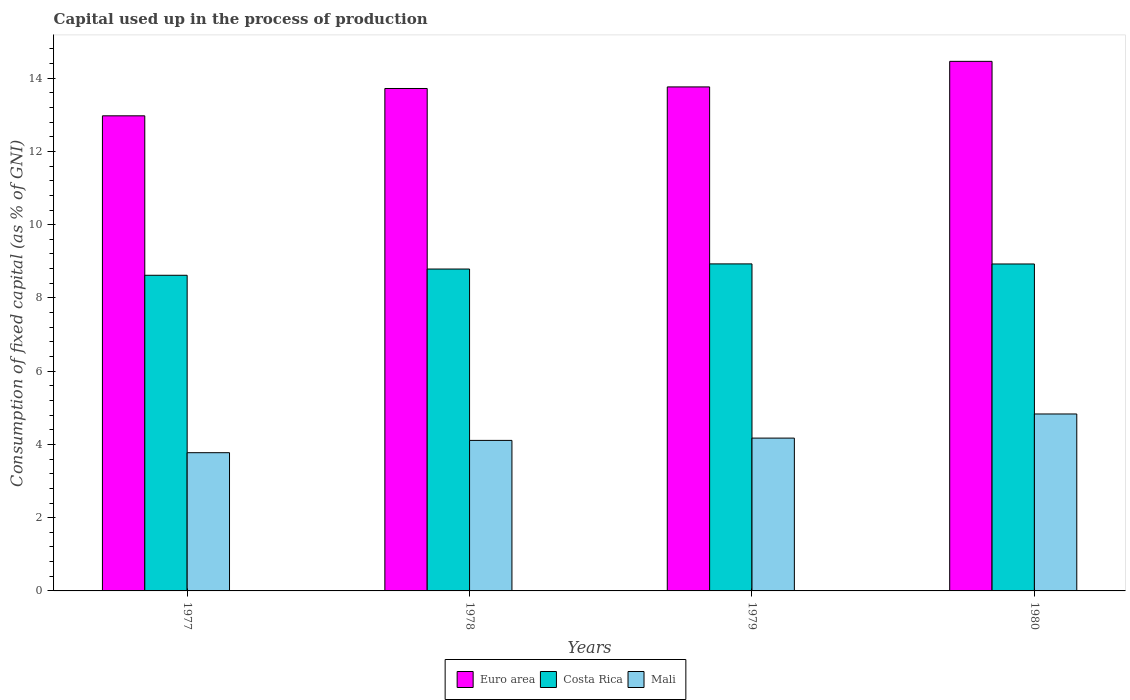How many different coloured bars are there?
Offer a terse response. 3. How many groups of bars are there?
Give a very brief answer. 4. Are the number of bars on each tick of the X-axis equal?
Your response must be concise. Yes. How many bars are there on the 1st tick from the right?
Your answer should be very brief. 3. What is the capital used up in the process of production in Mali in 1979?
Your response must be concise. 4.17. Across all years, what is the maximum capital used up in the process of production in Costa Rica?
Make the answer very short. 8.93. Across all years, what is the minimum capital used up in the process of production in Euro area?
Provide a short and direct response. 12.97. In which year was the capital used up in the process of production in Euro area maximum?
Offer a terse response. 1980. In which year was the capital used up in the process of production in Mali minimum?
Offer a very short reply. 1977. What is the total capital used up in the process of production in Mali in the graph?
Offer a terse response. 16.89. What is the difference between the capital used up in the process of production in Euro area in 1978 and that in 1980?
Your answer should be compact. -0.74. What is the difference between the capital used up in the process of production in Mali in 1977 and the capital used up in the process of production in Costa Rica in 1980?
Ensure brevity in your answer.  -5.15. What is the average capital used up in the process of production in Mali per year?
Offer a terse response. 4.22. In the year 1977, what is the difference between the capital used up in the process of production in Costa Rica and capital used up in the process of production in Euro area?
Your answer should be compact. -4.35. What is the ratio of the capital used up in the process of production in Mali in 1977 to that in 1979?
Offer a very short reply. 0.9. Is the difference between the capital used up in the process of production in Costa Rica in 1978 and 1979 greater than the difference between the capital used up in the process of production in Euro area in 1978 and 1979?
Your response must be concise. No. What is the difference between the highest and the second highest capital used up in the process of production in Euro area?
Make the answer very short. 0.7. What is the difference between the highest and the lowest capital used up in the process of production in Mali?
Keep it short and to the point. 1.06. Is the sum of the capital used up in the process of production in Costa Rica in 1978 and 1979 greater than the maximum capital used up in the process of production in Euro area across all years?
Keep it short and to the point. Yes. What does the 3rd bar from the left in 1977 represents?
Provide a short and direct response. Mali. How many bars are there?
Give a very brief answer. 12. Are all the bars in the graph horizontal?
Provide a short and direct response. No. How many years are there in the graph?
Offer a terse response. 4. Does the graph contain any zero values?
Make the answer very short. No. Where does the legend appear in the graph?
Ensure brevity in your answer.  Bottom center. How many legend labels are there?
Offer a terse response. 3. How are the legend labels stacked?
Give a very brief answer. Horizontal. What is the title of the graph?
Offer a terse response. Capital used up in the process of production. What is the label or title of the X-axis?
Provide a succinct answer. Years. What is the label or title of the Y-axis?
Your answer should be compact. Consumption of fixed capital (as % of GNI). What is the Consumption of fixed capital (as % of GNI) in Euro area in 1977?
Offer a very short reply. 12.97. What is the Consumption of fixed capital (as % of GNI) of Costa Rica in 1977?
Your answer should be very brief. 8.62. What is the Consumption of fixed capital (as % of GNI) in Mali in 1977?
Give a very brief answer. 3.77. What is the Consumption of fixed capital (as % of GNI) in Euro area in 1978?
Ensure brevity in your answer.  13.72. What is the Consumption of fixed capital (as % of GNI) in Costa Rica in 1978?
Keep it short and to the point. 8.79. What is the Consumption of fixed capital (as % of GNI) of Mali in 1978?
Provide a short and direct response. 4.11. What is the Consumption of fixed capital (as % of GNI) in Euro area in 1979?
Offer a terse response. 13.76. What is the Consumption of fixed capital (as % of GNI) in Costa Rica in 1979?
Provide a succinct answer. 8.93. What is the Consumption of fixed capital (as % of GNI) in Mali in 1979?
Provide a succinct answer. 4.17. What is the Consumption of fixed capital (as % of GNI) of Euro area in 1980?
Offer a very short reply. 14.46. What is the Consumption of fixed capital (as % of GNI) of Costa Rica in 1980?
Ensure brevity in your answer.  8.93. What is the Consumption of fixed capital (as % of GNI) in Mali in 1980?
Provide a succinct answer. 4.83. Across all years, what is the maximum Consumption of fixed capital (as % of GNI) in Euro area?
Provide a short and direct response. 14.46. Across all years, what is the maximum Consumption of fixed capital (as % of GNI) in Costa Rica?
Offer a terse response. 8.93. Across all years, what is the maximum Consumption of fixed capital (as % of GNI) of Mali?
Provide a succinct answer. 4.83. Across all years, what is the minimum Consumption of fixed capital (as % of GNI) of Euro area?
Provide a succinct answer. 12.97. Across all years, what is the minimum Consumption of fixed capital (as % of GNI) of Costa Rica?
Make the answer very short. 8.62. Across all years, what is the minimum Consumption of fixed capital (as % of GNI) of Mali?
Ensure brevity in your answer.  3.77. What is the total Consumption of fixed capital (as % of GNI) of Euro area in the graph?
Make the answer very short. 54.91. What is the total Consumption of fixed capital (as % of GNI) of Costa Rica in the graph?
Your response must be concise. 35.26. What is the total Consumption of fixed capital (as % of GNI) in Mali in the graph?
Offer a very short reply. 16.89. What is the difference between the Consumption of fixed capital (as % of GNI) in Euro area in 1977 and that in 1978?
Ensure brevity in your answer.  -0.75. What is the difference between the Consumption of fixed capital (as % of GNI) of Costa Rica in 1977 and that in 1978?
Offer a very short reply. -0.17. What is the difference between the Consumption of fixed capital (as % of GNI) in Mali in 1977 and that in 1978?
Your response must be concise. -0.34. What is the difference between the Consumption of fixed capital (as % of GNI) in Euro area in 1977 and that in 1979?
Provide a succinct answer. -0.79. What is the difference between the Consumption of fixed capital (as % of GNI) in Costa Rica in 1977 and that in 1979?
Offer a very short reply. -0.31. What is the difference between the Consumption of fixed capital (as % of GNI) of Mali in 1977 and that in 1979?
Your response must be concise. -0.4. What is the difference between the Consumption of fixed capital (as % of GNI) in Euro area in 1977 and that in 1980?
Offer a very short reply. -1.49. What is the difference between the Consumption of fixed capital (as % of GNI) of Costa Rica in 1977 and that in 1980?
Give a very brief answer. -0.31. What is the difference between the Consumption of fixed capital (as % of GNI) in Mali in 1977 and that in 1980?
Provide a succinct answer. -1.06. What is the difference between the Consumption of fixed capital (as % of GNI) in Euro area in 1978 and that in 1979?
Your answer should be compact. -0.04. What is the difference between the Consumption of fixed capital (as % of GNI) in Costa Rica in 1978 and that in 1979?
Your answer should be compact. -0.14. What is the difference between the Consumption of fixed capital (as % of GNI) in Mali in 1978 and that in 1979?
Offer a very short reply. -0.06. What is the difference between the Consumption of fixed capital (as % of GNI) of Euro area in 1978 and that in 1980?
Your response must be concise. -0.74. What is the difference between the Consumption of fixed capital (as % of GNI) in Costa Rica in 1978 and that in 1980?
Make the answer very short. -0.14. What is the difference between the Consumption of fixed capital (as % of GNI) of Mali in 1978 and that in 1980?
Your answer should be compact. -0.72. What is the difference between the Consumption of fixed capital (as % of GNI) of Euro area in 1979 and that in 1980?
Provide a short and direct response. -0.7. What is the difference between the Consumption of fixed capital (as % of GNI) in Costa Rica in 1979 and that in 1980?
Ensure brevity in your answer.  0. What is the difference between the Consumption of fixed capital (as % of GNI) of Mali in 1979 and that in 1980?
Provide a short and direct response. -0.66. What is the difference between the Consumption of fixed capital (as % of GNI) of Euro area in 1977 and the Consumption of fixed capital (as % of GNI) of Costa Rica in 1978?
Give a very brief answer. 4.18. What is the difference between the Consumption of fixed capital (as % of GNI) of Euro area in 1977 and the Consumption of fixed capital (as % of GNI) of Mali in 1978?
Provide a short and direct response. 8.86. What is the difference between the Consumption of fixed capital (as % of GNI) of Costa Rica in 1977 and the Consumption of fixed capital (as % of GNI) of Mali in 1978?
Provide a short and direct response. 4.51. What is the difference between the Consumption of fixed capital (as % of GNI) in Euro area in 1977 and the Consumption of fixed capital (as % of GNI) in Costa Rica in 1979?
Your answer should be very brief. 4.04. What is the difference between the Consumption of fixed capital (as % of GNI) of Euro area in 1977 and the Consumption of fixed capital (as % of GNI) of Mali in 1979?
Provide a succinct answer. 8.8. What is the difference between the Consumption of fixed capital (as % of GNI) in Costa Rica in 1977 and the Consumption of fixed capital (as % of GNI) in Mali in 1979?
Your answer should be compact. 4.45. What is the difference between the Consumption of fixed capital (as % of GNI) in Euro area in 1977 and the Consumption of fixed capital (as % of GNI) in Costa Rica in 1980?
Keep it short and to the point. 4.05. What is the difference between the Consumption of fixed capital (as % of GNI) in Euro area in 1977 and the Consumption of fixed capital (as % of GNI) in Mali in 1980?
Give a very brief answer. 8.14. What is the difference between the Consumption of fixed capital (as % of GNI) in Costa Rica in 1977 and the Consumption of fixed capital (as % of GNI) in Mali in 1980?
Your answer should be compact. 3.79. What is the difference between the Consumption of fixed capital (as % of GNI) of Euro area in 1978 and the Consumption of fixed capital (as % of GNI) of Costa Rica in 1979?
Offer a terse response. 4.79. What is the difference between the Consumption of fixed capital (as % of GNI) in Euro area in 1978 and the Consumption of fixed capital (as % of GNI) in Mali in 1979?
Make the answer very short. 9.55. What is the difference between the Consumption of fixed capital (as % of GNI) in Costa Rica in 1978 and the Consumption of fixed capital (as % of GNI) in Mali in 1979?
Your answer should be compact. 4.62. What is the difference between the Consumption of fixed capital (as % of GNI) in Euro area in 1978 and the Consumption of fixed capital (as % of GNI) in Costa Rica in 1980?
Provide a short and direct response. 4.79. What is the difference between the Consumption of fixed capital (as % of GNI) of Euro area in 1978 and the Consumption of fixed capital (as % of GNI) of Mali in 1980?
Provide a short and direct response. 8.89. What is the difference between the Consumption of fixed capital (as % of GNI) of Costa Rica in 1978 and the Consumption of fixed capital (as % of GNI) of Mali in 1980?
Provide a succinct answer. 3.96. What is the difference between the Consumption of fixed capital (as % of GNI) of Euro area in 1979 and the Consumption of fixed capital (as % of GNI) of Costa Rica in 1980?
Offer a terse response. 4.84. What is the difference between the Consumption of fixed capital (as % of GNI) in Euro area in 1979 and the Consumption of fixed capital (as % of GNI) in Mali in 1980?
Offer a terse response. 8.93. What is the difference between the Consumption of fixed capital (as % of GNI) of Costa Rica in 1979 and the Consumption of fixed capital (as % of GNI) of Mali in 1980?
Keep it short and to the point. 4.1. What is the average Consumption of fixed capital (as % of GNI) of Euro area per year?
Offer a terse response. 13.73. What is the average Consumption of fixed capital (as % of GNI) in Costa Rica per year?
Your response must be concise. 8.82. What is the average Consumption of fixed capital (as % of GNI) of Mali per year?
Your answer should be compact. 4.22. In the year 1977, what is the difference between the Consumption of fixed capital (as % of GNI) of Euro area and Consumption of fixed capital (as % of GNI) of Costa Rica?
Your response must be concise. 4.35. In the year 1977, what is the difference between the Consumption of fixed capital (as % of GNI) in Euro area and Consumption of fixed capital (as % of GNI) in Mali?
Provide a short and direct response. 9.2. In the year 1977, what is the difference between the Consumption of fixed capital (as % of GNI) in Costa Rica and Consumption of fixed capital (as % of GNI) in Mali?
Provide a succinct answer. 4.84. In the year 1978, what is the difference between the Consumption of fixed capital (as % of GNI) in Euro area and Consumption of fixed capital (as % of GNI) in Costa Rica?
Keep it short and to the point. 4.93. In the year 1978, what is the difference between the Consumption of fixed capital (as % of GNI) of Euro area and Consumption of fixed capital (as % of GNI) of Mali?
Your answer should be compact. 9.61. In the year 1978, what is the difference between the Consumption of fixed capital (as % of GNI) of Costa Rica and Consumption of fixed capital (as % of GNI) of Mali?
Offer a terse response. 4.68. In the year 1979, what is the difference between the Consumption of fixed capital (as % of GNI) of Euro area and Consumption of fixed capital (as % of GNI) of Costa Rica?
Ensure brevity in your answer.  4.83. In the year 1979, what is the difference between the Consumption of fixed capital (as % of GNI) of Euro area and Consumption of fixed capital (as % of GNI) of Mali?
Your answer should be compact. 9.59. In the year 1979, what is the difference between the Consumption of fixed capital (as % of GNI) in Costa Rica and Consumption of fixed capital (as % of GNI) in Mali?
Your answer should be compact. 4.76. In the year 1980, what is the difference between the Consumption of fixed capital (as % of GNI) in Euro area and Consumption of fixed capital (as % of GNI) in Costa Rica?
Your response must be concise. 5.53. In the year 1980, what is the difference between the Consumption of fixed capital (as % of GNI) of Euro area and Consumption of fixed capital (as % of GNI) of Mali?
Offer a terse response. 9.63. In the year 1980, what is the difference between the Consumption of fixed capital (as % of GNI) of Costa Rica and Consumption of fixed capital (as % of GNI) of Mali?
Provide a succinct answer. 4.1. What is the ratio of the Consumption of fixed capital (as % of GNI) of Euro area in 1977 to that in 1978?
Ensure brevity in your answer.  0.95. What is the ratio of the Consumption of fixed capital (as % of GNI) in Costa Rica in 1977 to that in 1978?
Provide a succinct answer. 0.98. What is the ratio of the Consumption of fixed capital (as % of GNI) of Mali in 1977 to that in 1978?
Offer a terse response. 0.92. What is the ratio of the Consumption of fixed capital (as % of GNI) in Euro area in 1977 to that in 1979?
Ensure brevity in your answer.  0.94. What is the ratio of the Consumption of fixed capital (as % of GNI) of Costa Rica in 1977 to that in 1979?
Your answer should be very brief. 0.97. What is the ratio of the Consumption of fixed capital (as % of GNI) of Mali in 1977 to that in 1979?
Offer a terse response. 0.9. What is the ratio of the Consumption of fixed capital (as % of GNI) of Euro area in 1977 to that in 1980?
Your answer should be very brief. 0.9. What is the ratio of the Consumption of fixed capital (as % of GNI) of Costa Rica in 1977 to that in 1980?
Offer a very short reply. 0.97. What is the ratio of the Consumption of fixed capital (as % of GNI) in Mali in 1977 to that in 1980?
Ensure brevity in your answer.  0.78. What is the ratio of the Consumption of fixed capital (as % of GNI) of Euro area in 1978 to that in 1979?
Make the answer very short. 1. What is the ratio of the Consumption of fixed capital (as % of GNI) of Costa Rica in 1978 to that in 1979?
Your answer should be compact. 0.98. What is the ratio of the Consumption of fixed capital (as % of GNI) in Mali in 1978 to that in 1979?
Your answer should be very brief. 0.98. What is the ratio of the Consumption of fixed capital (as % of GNI) in Euro area in 1978 to that in 1980?
Keep it short and to the point. 0.95. What is the ratio of the Consumption of fixed capital (as % of GNI) in Costa Rica in 1978 to that in 1980?
Your answer should be compact. 0.98. What is the ratio of the Consumption of fixed capital (as % of GNI) in Mali in 1978 to that in 1980?
Offer a terse response. 0.85. What is the ratio of the Consumption of fixed capital (as % of GNI) of Euro area in 1979 to that in 1980?
Your answer should be compact. 0.95. What is the ratio of the Consumption of fixed capital (as % of GNI) of Mali in 1979 to that in 1980?
Provide a succinct answer. 0.86. What is the difference between the highest and the second highest Consumption of fixed capital (as % of GNI) of Euro area?
Offer a terse response. 0.7. What is the difference between the highest and the second highest Consumption of fixed capital (as % of GNI) in Costa Rica?
Your answer should be very brief. 0. What is the difference between the highest and the second highest Consumption of fixed capital (as % of GNI) of Mali?
Give a very brief answer. 0.66. What is the difference between the highest and the lowest Consumption of fixed capital (as % of GNI) in Euro area?
Offer a terse response. 1.49. What is the difference between the highest and the lowest Consumption of fixed capital (as % of GNI) in Costa Rica?
Your answer should be compact. 0.31. What is the difference between the highest and the lowest Consumption of fixed capital (as % of GNI) of Mali?
Your response must be concise. 1.06. 